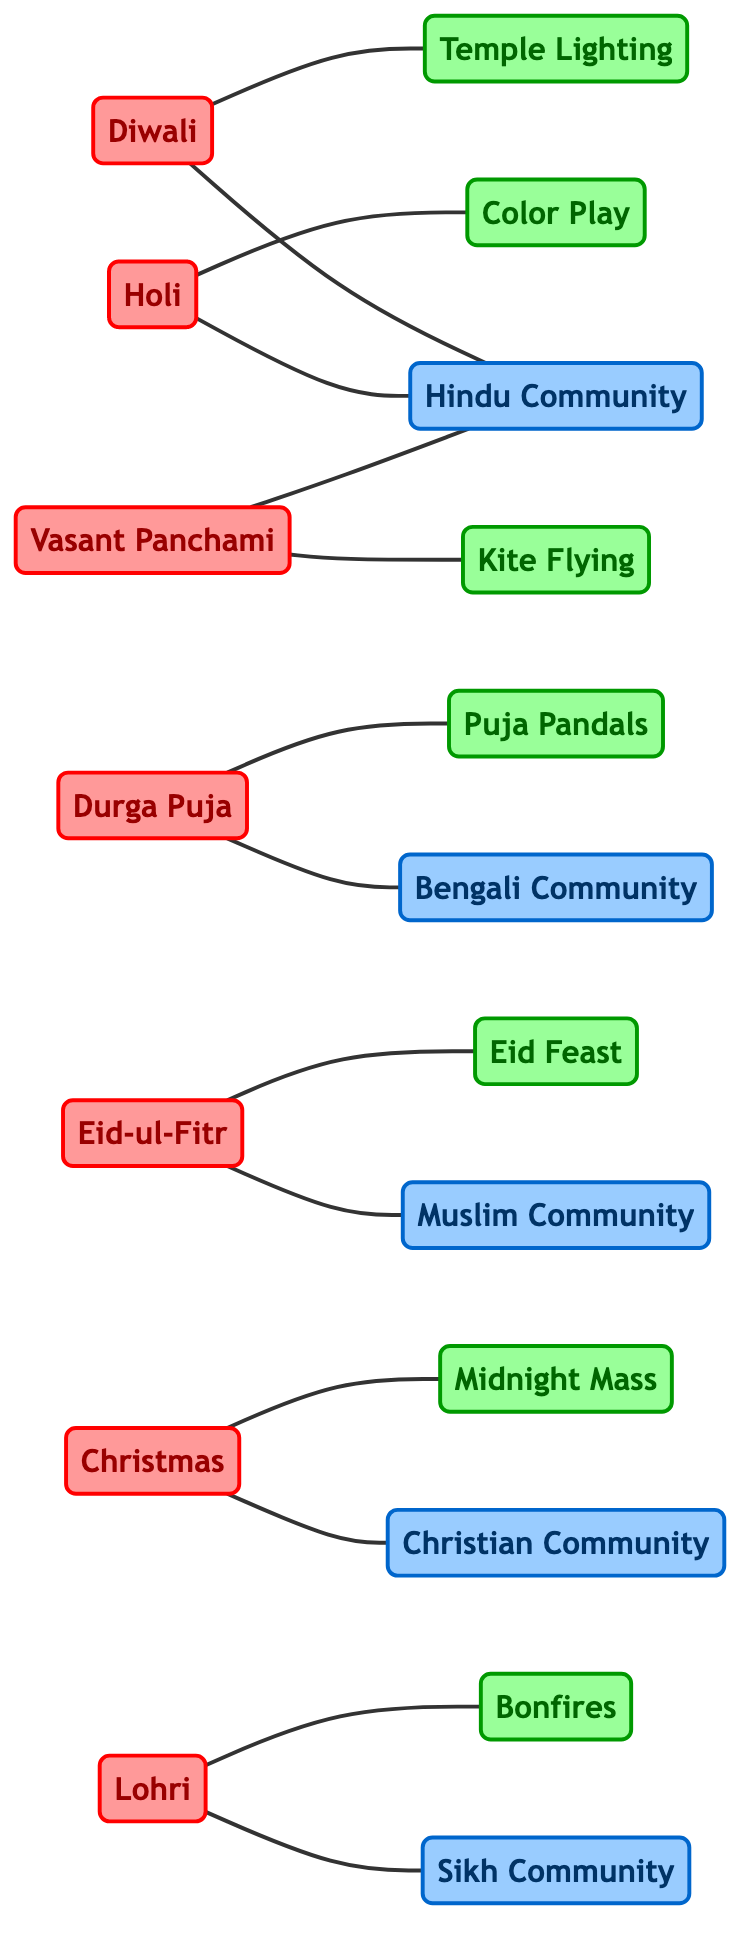What traditional festival is associated with the Sikh Community? The diagram shows that Lohri is connected to the Sikh Community, indicating it as a traditional festival related to this community.
Answer: Lohri How many traditional festivals are represented in the diagram? By counting the nodes labeled as festivals, we find Diwali, Holi, Durga Puja, Eid-ul-Fitr, Christmas, Vasant Panchami, and Lohri, totaling seven traditional festivals.
Answer: 7 Which community is linked to the Eid Feast? The diagram connects the Eid Feast to the Muslim Community, indicating that they are directly related in this context.
Answer: Muslim Community What activities are associated with Vasant Panchami? The diagram links Vasant Panchami to two activities: Kite Flying and the Hindu Community, meaning these are the associated activities for this festival.
Answer: Kite Flying How many edges connect the Hindu Community to traditional festivals? Reviewing the edges, we find that the Hindu Community is linked to four festivals: Diwali, Holi, Vasant Panchami, making the total count of edges connecting to this community is four.
Answer: 4 Which community celebrates Durga Puja? The diagram directly connects Durga Puja to the Bengali Community, indicating that this festival is specifically celebrated by them.
Answer: Bengali Community What's the relationship between Holi and Color Play? The connection between Holi and Color Play in the diagram shows that Holi is associated with the activity known as Color Play during the celebrations.
Answer: Color Play Which community relates to Christmas festivals? The diagram connects Christmas to the Christian Community, clearly establishing that they are the community associated with this festival.
Answer: Christian Community What is the total number of edges in the graph? By counting each connection listed in the edges section, we find a total of 14 edges representing the relationships between festivals, communities, and activities.
Answer: 14 